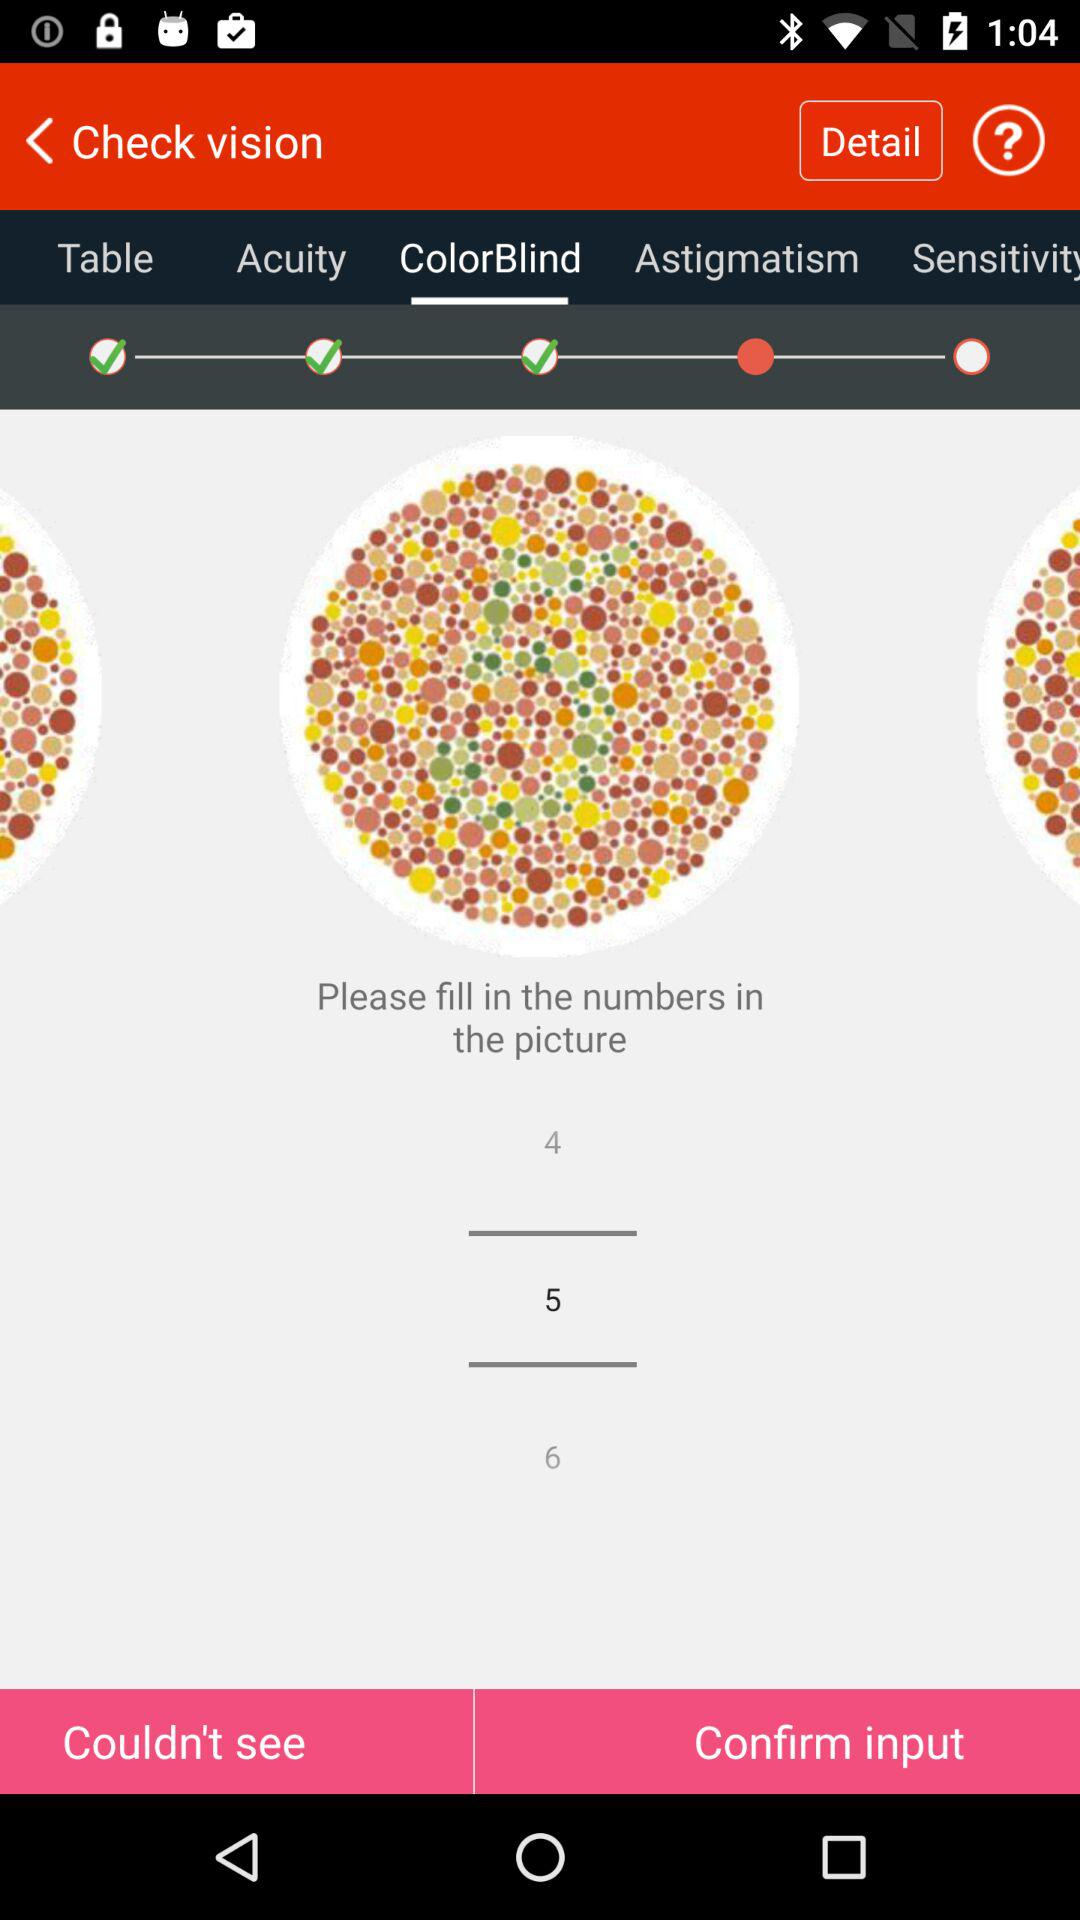How many color-blindness pictures are there in total?
When the provided information is insufficient, respond with <no answer>. <no answer> 